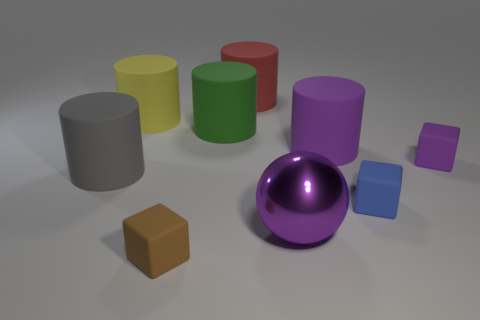Subtract all big red rubber cylinders. How many cylinders are left? 4 Subtract 1 balls. How many balls are left? 0 Subtract all yellow cylinders. How many cylinders are left? 4 Subtract all balls. How many objects are left? 8 Subtract all blue balls. How many brown blocks are left? 1 Subtract all cyan balls. Subtract all red cylinders. How many balls are left? 1 Add 6 shiny things. How many shiny things are left? 7 Add 9 small cyan shiny objects. How many small cyan shiny objects exist? 9 Subtract 0 blue balls. How many objects are left? 9 Subtract all yellow rubber balls. Subtract all big purple balls. How many objects are left? 8 